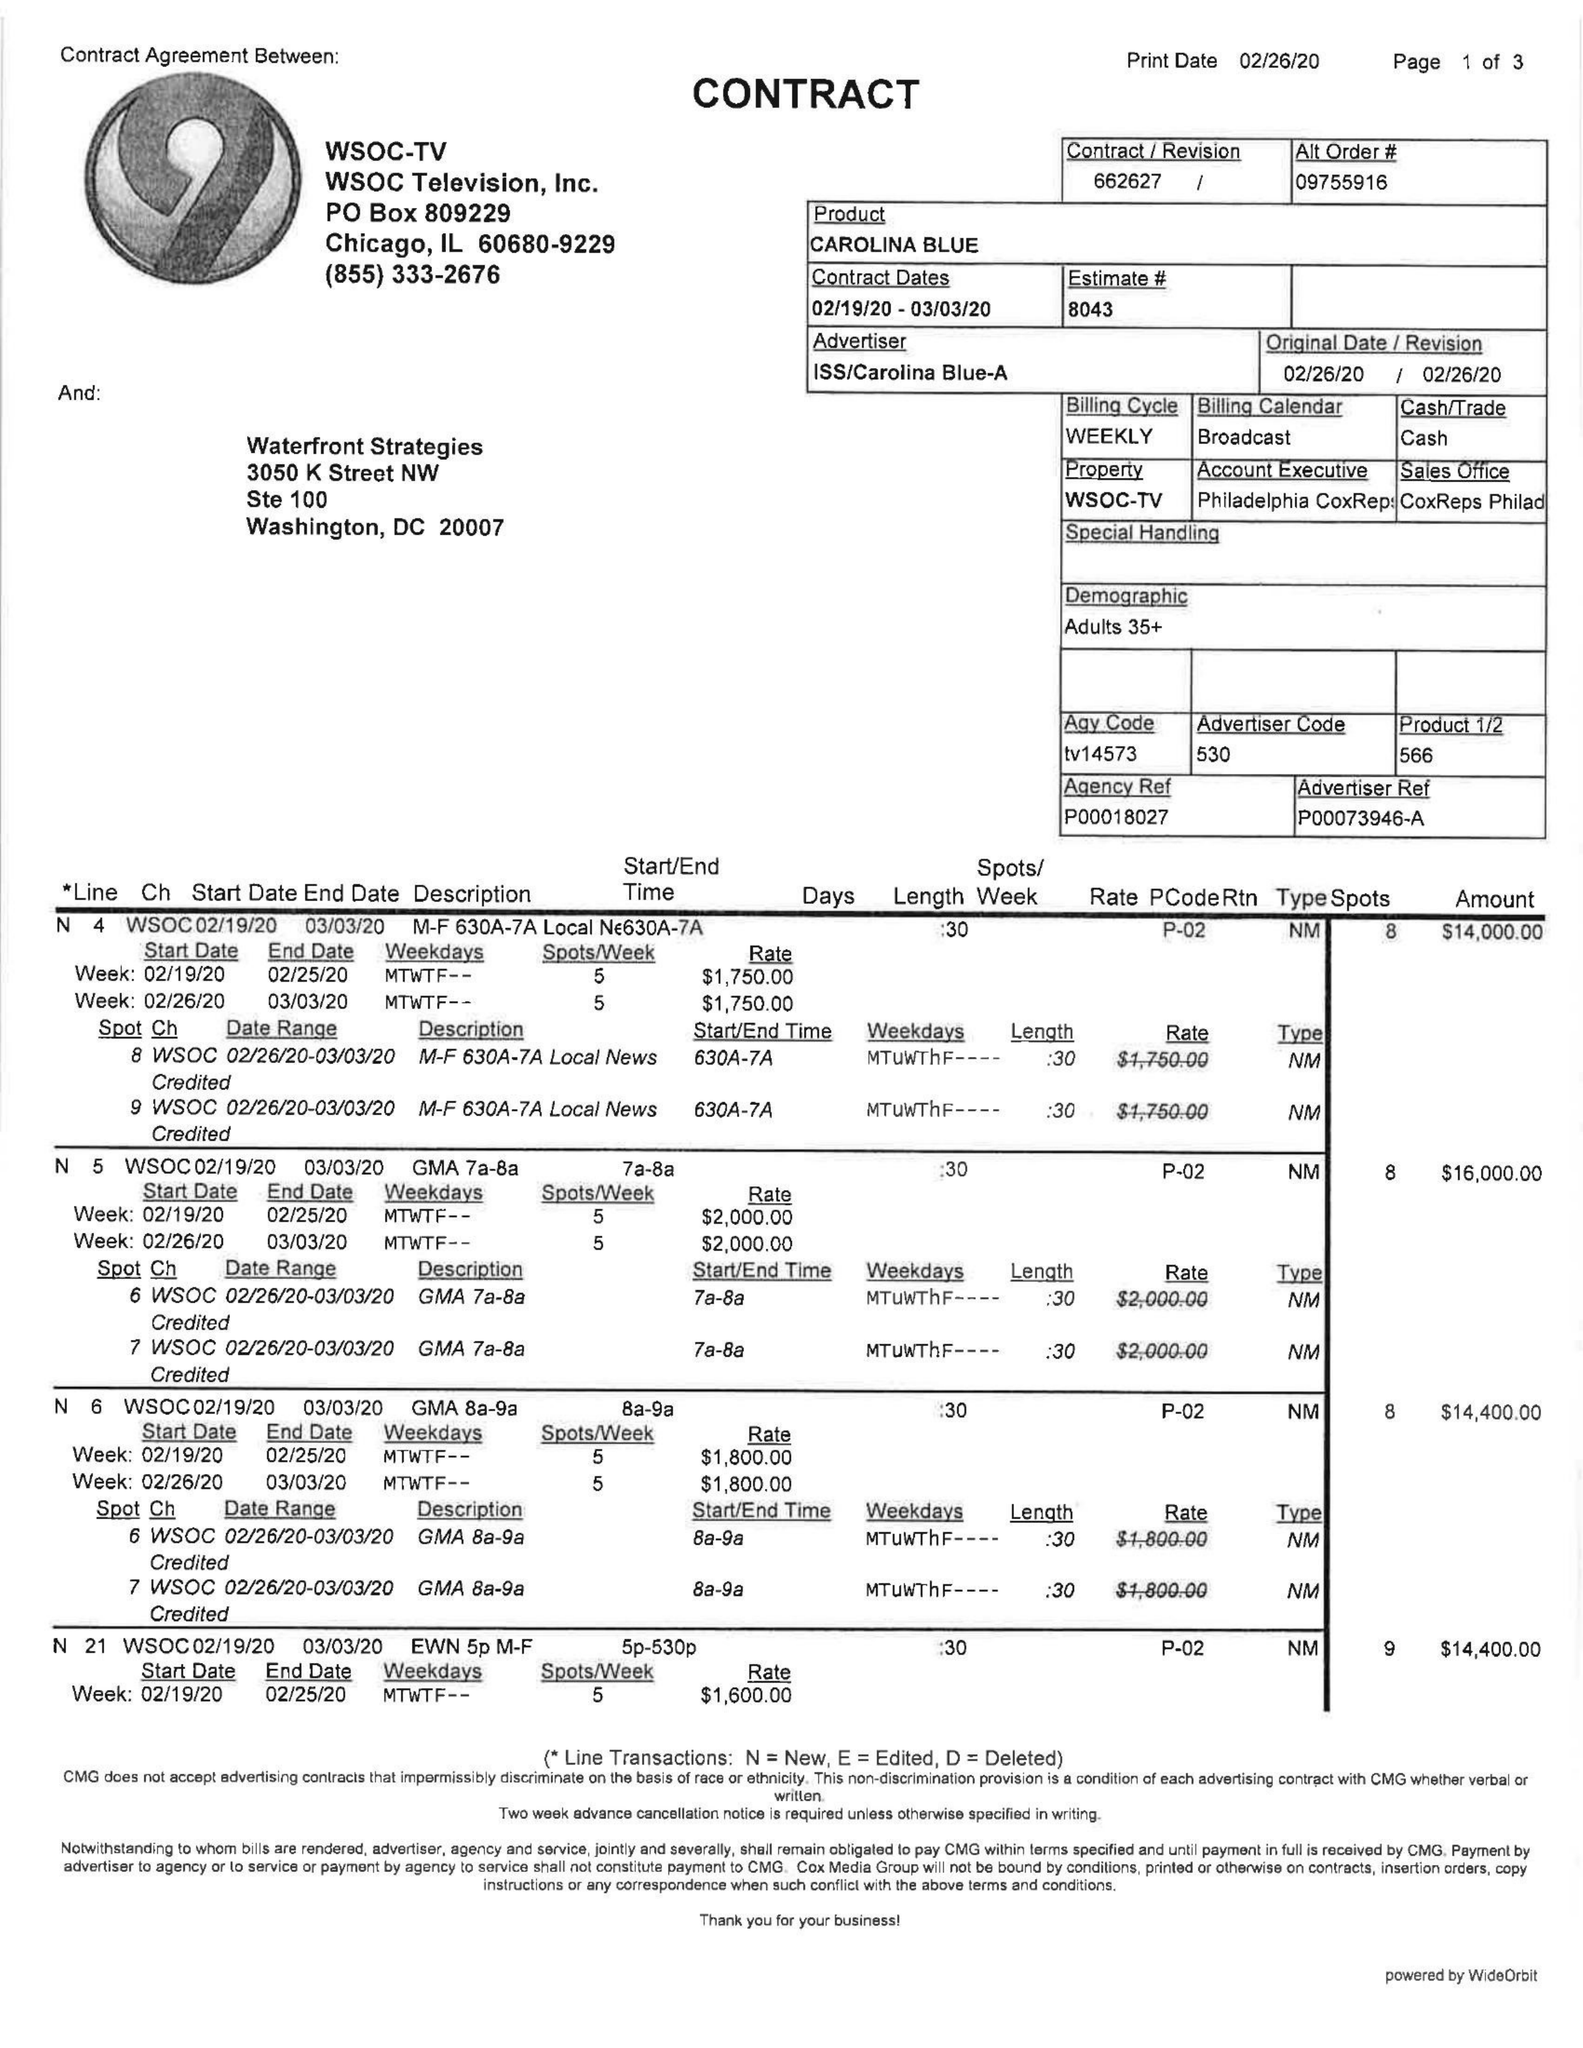What is the value for the gross_amount?
Answer the question using a single word or phrase. 363400.00 